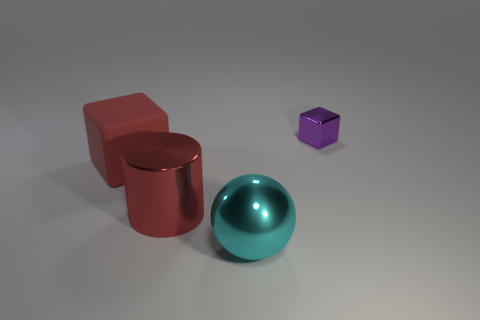Add 1 shiny objects. How many objects exist? 5 Subtract all cylinders. How many objects are left? 3 Subtract 1 red cylinders. How many objects are left? 3 Subtract all brown rubber spheres. Subtract all tiny objects. How many objects are left? 3 Add 3 red objects. How many red objects are left? 5 Add 2 red blocks. How many red blocks exist? 3 